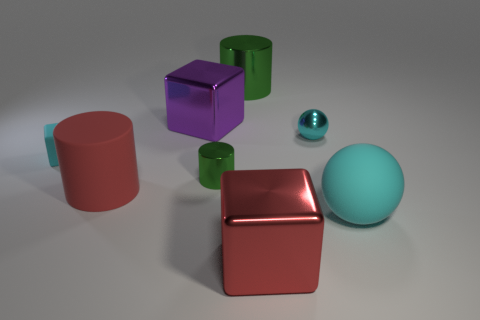Is the ball that is on the right side of the small cyan metal object made of the same material as the large red cube?
Keep it short and to the point. No. Is there anything else that has the same material as the large red cube?
Your answer should be compact. Yes. There is a metal block that is left of the block that is in front of the big red rubber cylinder; how many big red metallic things are behind it?
Give a very brief answer. 0. What is the size of the purple shiny block?
Ensure brevity in your answer.  Large. Is the color of the tiny metal ball the same as the small metallic cylinder?
Offer a terse response. No. What is the size of the cyan rubber thing behind the big red cylinder?
Your answer should be very brief. Small. Does the matte block left of the matte cylinder have the same color as the big metallic block that is on the right side of the small shiny cylinder?
Provide a succinct answer. No. How many other objects are there of the same shape as the large red shiny object?
Your response must be concise. 2. Are there an equal number of small cyan rubber things in front of the cyan block and tiny cyan shiny spheres behind the big purple metallic cube?
Your answer should be very brief. Yes. Are the tiny thing behind the tiny cyan matte cube and the big cylinder to the right of the red matte cylinder made of the same material?
Provide a succinct answer. Yes. 